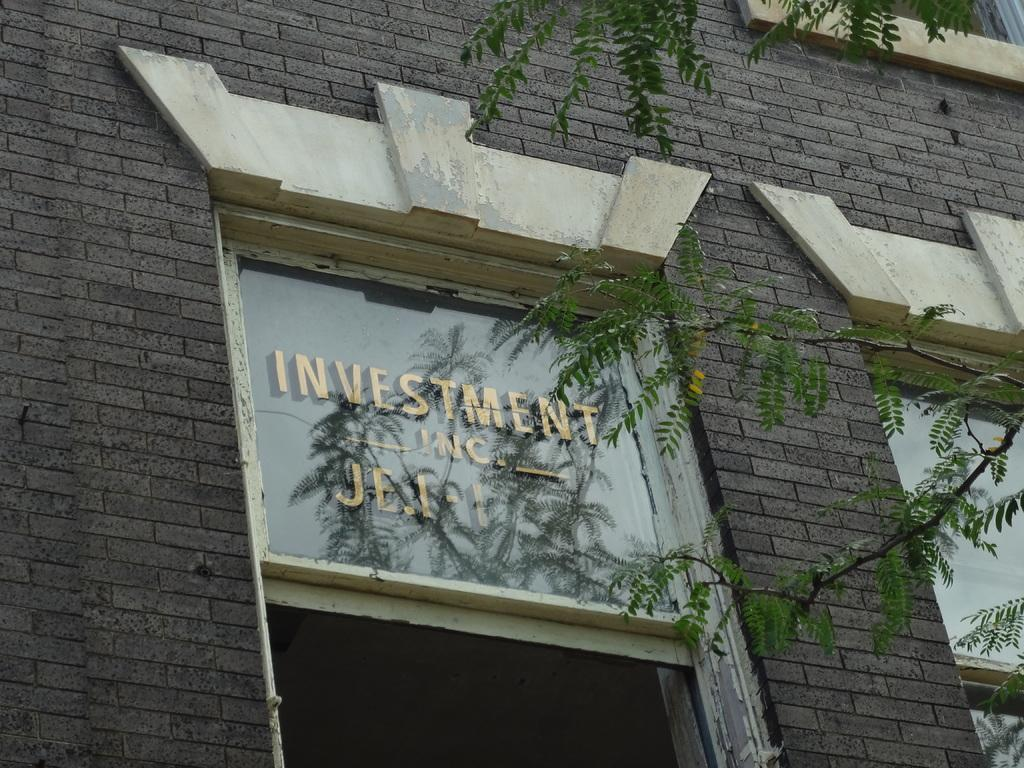What type of structure is visible in the image? There is a brick wall in the image. What architectural feature can be seen in the brick wall? There is a window in the image. What is written or drawn on the glass of the window? There is text on the glass of the window. What type of vegetation is visible in the image? Leaves are visible in the image. What is the reflection of in the window? The reflection of leaves and the sky is visible on the window. Can you tell me how many squirrels are visible on the glass of the window? There are no squirrels visible on the glass of the window; the image only features leaves and the sky in the reflections. 